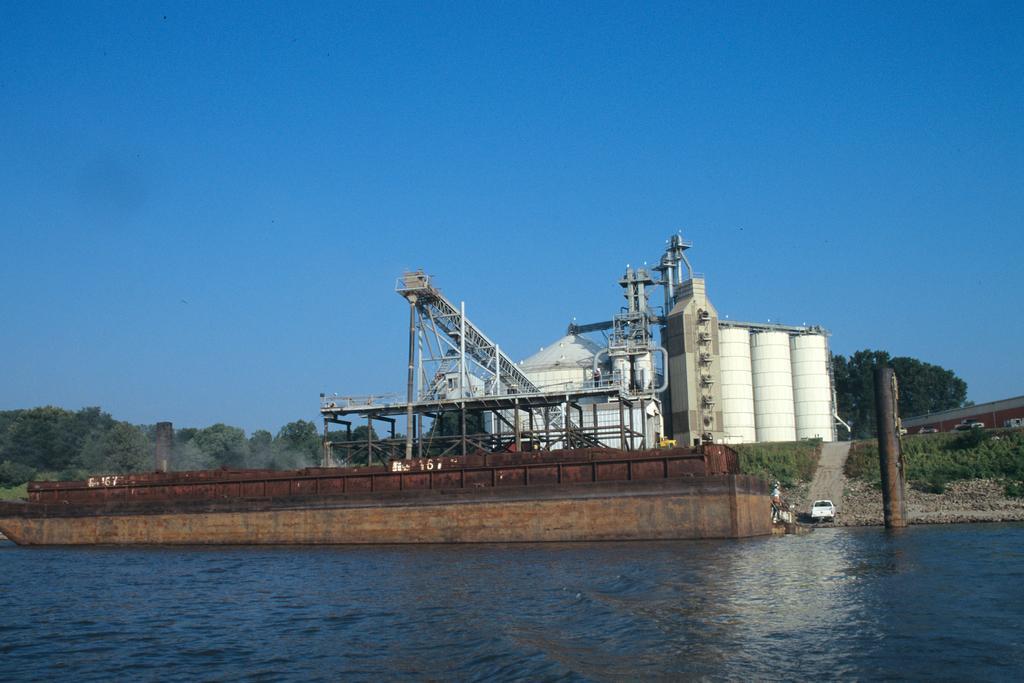Could you give a brief overview of what you see in this image? In this picture I can see a factory, a vehicle and some objects on the ground. Here I can see water. In the background I can see trees and the sky. 